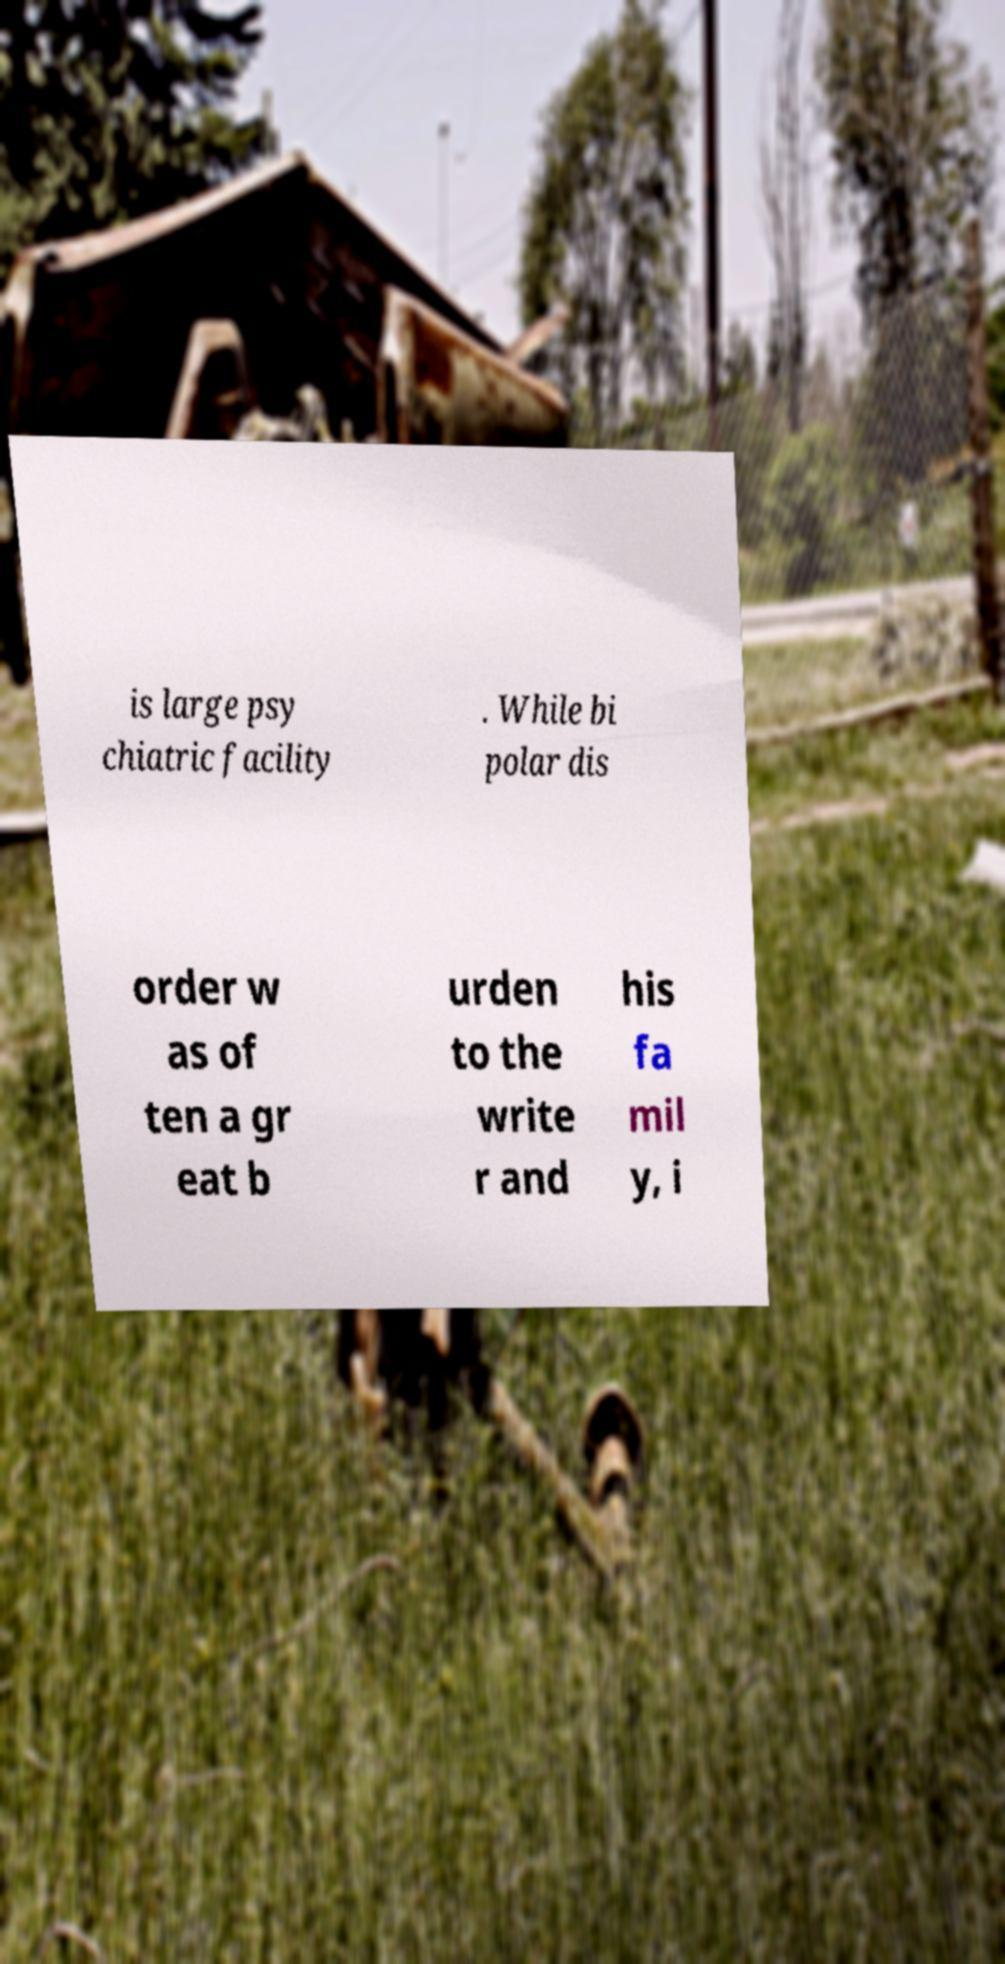Can you read and provide the text displayed in the image?This photo seems to have some interesting text. Can you extract and type it out for me? is large psy chiatric facility . While bi polar dis order w as of ten a gr eat b urden to the write r and his fa mil y, i 